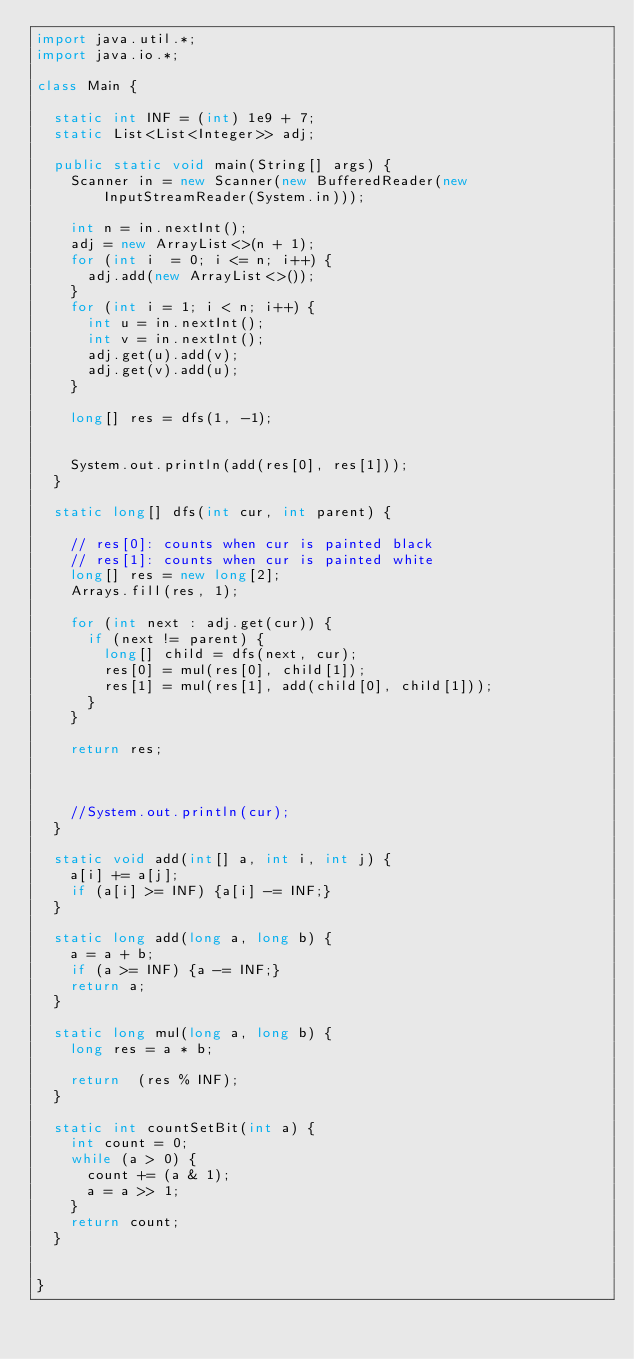<code> <loc_0><loc_0><loc_500><loc_500><_Java_>import java.util.*;
import java.io.*;
 
class Main {
 
  static int INF = (int) 1e9 + 7;
  static List<List<Integer>> adj;
 
  public static void main(String[] args) {
    Scanner in = new Scanner(new BufferedReader(new InputStreamReader(System.in)));
    
    int n = in.nextInt();
    adj = new ArrayList<>(n + 1);
    for (int i  = 0; i <= n; i++) {
      adj.add(new ArrayList<>());
    }
    for (int i = 1; i < n; i++) {
      int u = in.nextInt();
      int v = in.nextInt();
      adj.get(u).add(v);
      adj.get(v).add(u);
    }

    long[] res = dfs(1, -1);

   
    System.out.println(add(res[0], res[1]));
  }

  static long[] dfs(int cur, int parent) {

    // res[0]: counts when cur is painted black
    // res[1]: counts when cur is painted white
    long[] res = new long[2]; 
    Arrays.fill(res, 1);

    for (int next : adj.get(cur)) {
      if (next != parent) {
        long[] child = dfs(next, cur);
        res[0] = mul(res[0], child[1]);
        res[1] = mul(res[1], add(child[0], child[1]));
      }
    }

    return res;
    


    //System.out.println(cur);
  }

  static void add(int[] a, int i, int j) {
    a[i] += a[j];
    if (a[i] >= INF) {a[i] -= INF;}
  }

  static long add(long a, long b) {
    a = a + b;
    if (a >= INF) {a -= INF;}
    return a;
  }

  static long mul(long a, long b) {
    long res = a * b;
    
    return  (res % INF);
  }

  static int countSetBit(int a) {
    int count = 0; 
    while (a > 0) {
      count += (a & 1);
      a = a >> 1;
    }
    return count;
  }

 
}</code> 